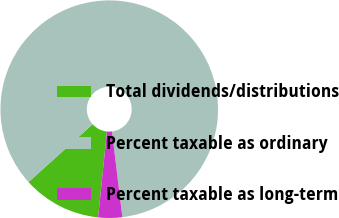Convert chart to OTSL. <chart><loc_0><loc_0><loc_500><loc_500><pie_chart><fcel>Total dividends/distributions<fcel>Percent taxable as ordinary<fcel>Percent taxable as long-term<nl><fcel>11.68%<fcel>84.76%<fcel>3.56%<nl></chart> 